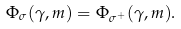Convert formula to latex. <formula><loc_0><loc_0><loc_500><loc_500>\Phi _ { \sigma } ( \gamma , m ) = \Phi _ { \sigma ^ { + } } ( \gamma , m ) .</formula> 